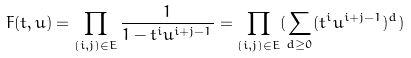Convert formula to latex. <formula><loc_0><loc_0><loc_500><loc_500>F ( t , u ) = \prod _ { ( i , j ) \in E } \frac { 1 } { 1 - t ^ { i } u ^ { i + j - 1 } } = \prod _ { ( i , j ) \in E } ( \sum _ { d \geq 0 } ( t ^ { i } u ^ { i + j - 1 } ) ^ { d } )</formula> 